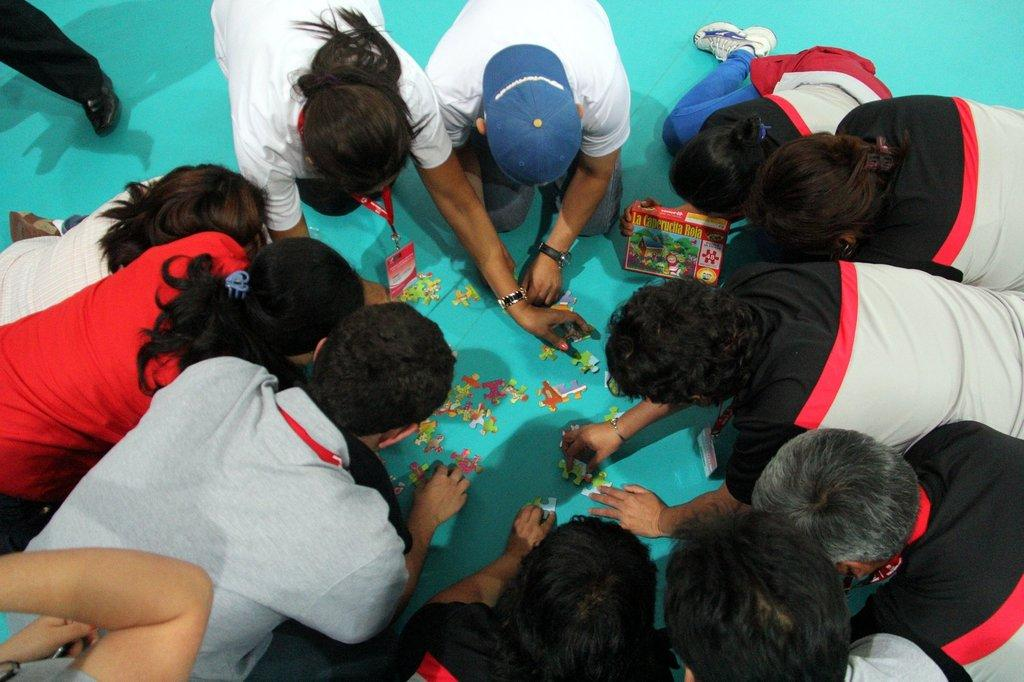How many people are in the image? There are persons in the image, but the exact number is not specified. What are the persons wearing? The persons are wearing clothes. What position are the persons in? The persons are sitting on their knees. What is in the middle of the image? There are jigsaw puzzles in the middle of the image. Can you describe any specific body part visible in the image? There is a person's leg visible in the top left of the image. What type of lead is being used to solve the jigsaw puzzles in the image? There is no mention of lead in the image, as jigsaw puzzles typically do not require lead for solving. What flavor of jam is being spread on the jigsaw puzzles in the image? There is no jam present in the image, and jigsaw puzzles are not typically associated with jam. 